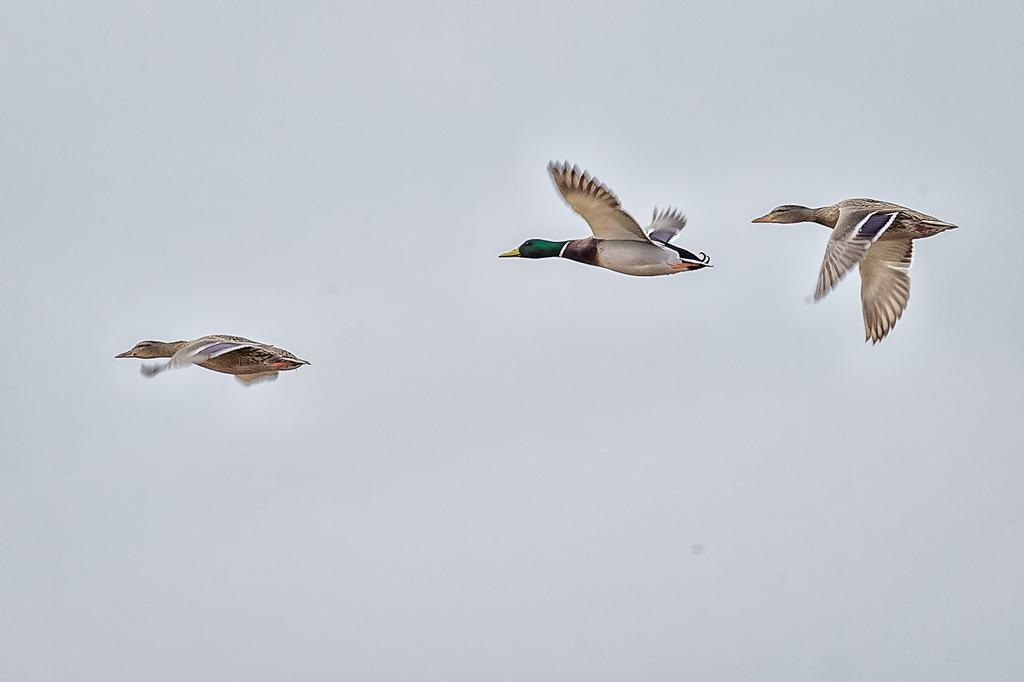What is happening in the image? There are birds flying in the image. What can be seen in the background of the image? The sky is visible in the background of the image. How many fish are swimming in the image? There are no fish present in the image; it features birds flying in the sky. What type of maid can be seen attending to the birds in the image? There is no maid present in the image; it only shows birds flying in the sky. 